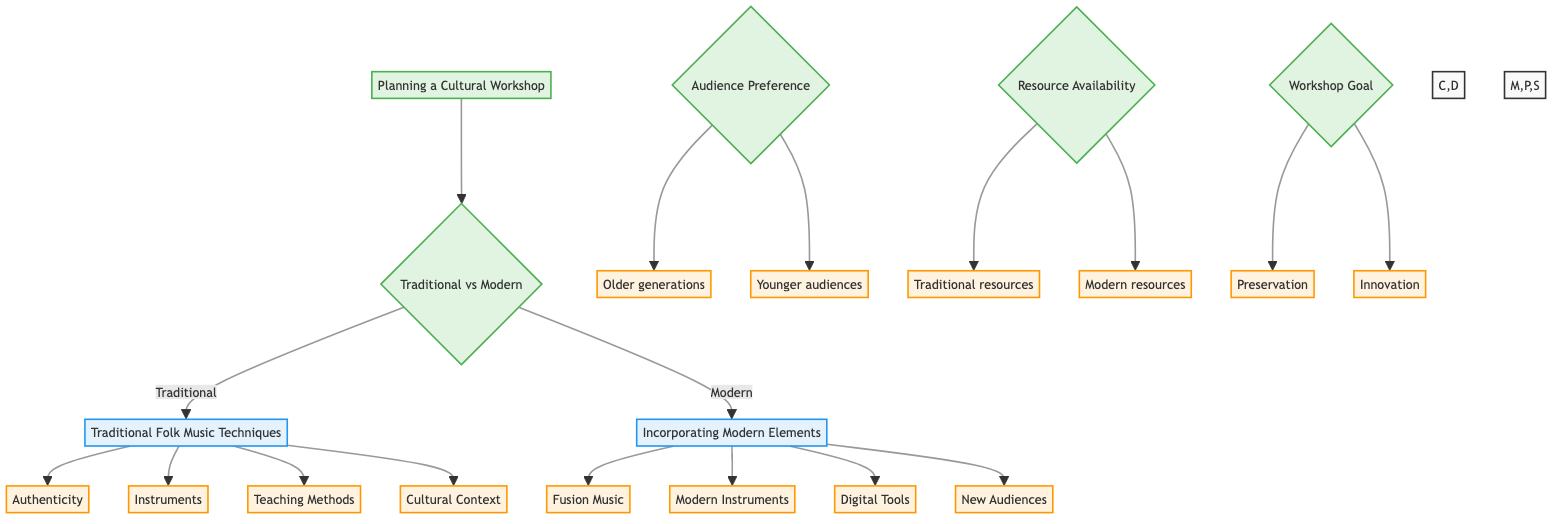What are the two main categories of the workshop? The diagram shows that the two main categories are "Traditional Folk Music Techniques" and "Incorporating Modern Elements." These options are the primary branches stemming from the initial decision node.
Answer: Traditional Folk Music Techniques and Incorporating Modern Elements How many considerations are there under Traditional Folk Music Techniques? By inspecting the "Traditional Folk Music Techniques" node, we can see four branches (Authenticity, Instruments, Teaching Methods, and Cultural Context), which represent the considerations under this category.
Answer: 4 Which consideration focuses on the methods of teaching? Looking at the options under "Traditional Folk Music Techniques," the node labeled "Teaching Methods" pertains specifically to how folk music should be taught.
Answer: Teaching Methods What is the criterion that includes Older generations and Younger audiences? The "Audience Preference" criterion, as depicted in the diagram, highlights subcriteria that specifically include Older generations who prefer traditional methods and Younger audiences open to modern elements.
Answer: Audience Preference Which modern element involves engaging global audiences? The consideration labeled "New Audiences" under "Incorporating Modern Elements" directly addresses the aim of reaching younger and global audiences using contemporary means such as social media and streaming.
Answer: New Audiences If the goal is innovation, what category would be pursued? Referring to the "Workshop Goal" criterion in the diagram, the option labeled "Innovation and experimentation" would be pursued if the main goal is to innovate rather than to preserve traditional culture.
Answer: Innovation What instruments are emphasized in Traditional Folk Music Techniques? The diagram lists "Instruments" as a consideration under "Traditional Folk Music Techniques," where traditional Bangladeshi instruments like the ektara, dotara, and tabla are specifically highlighted.
Answer: Traditional instruments Which modern tool is used for music production? In the "Incorporating Modern Elements" section, "Digital Tools" is the consideration that discusses the use of music production software, such as Ableton Live or GarageBand, for recording and sharing music.
Answer: Digital Tools How do traditional teaching methods differ from modern approaches? The "Teaching Methods" under "Traditional Folk Music Techniques" highlights the focus on oral traditions and mentor-apprentice relationships, while modern approaches involve structured learning with written notation. This requires a connection between the traditional and modern perspectives on teaching music.
Answer: Focus on oral traditions 